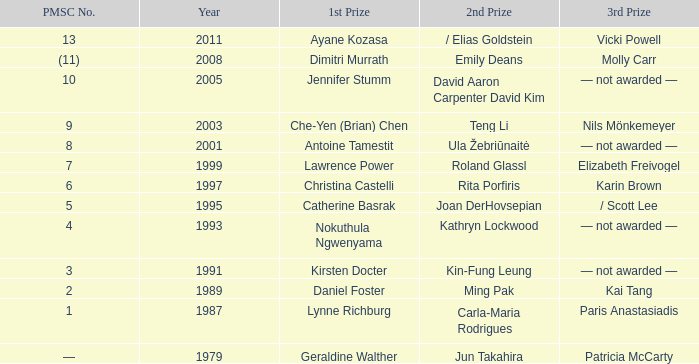What is the initial year when the 1st prize was awarded to che-yen (brian) chen? 2003.0. 